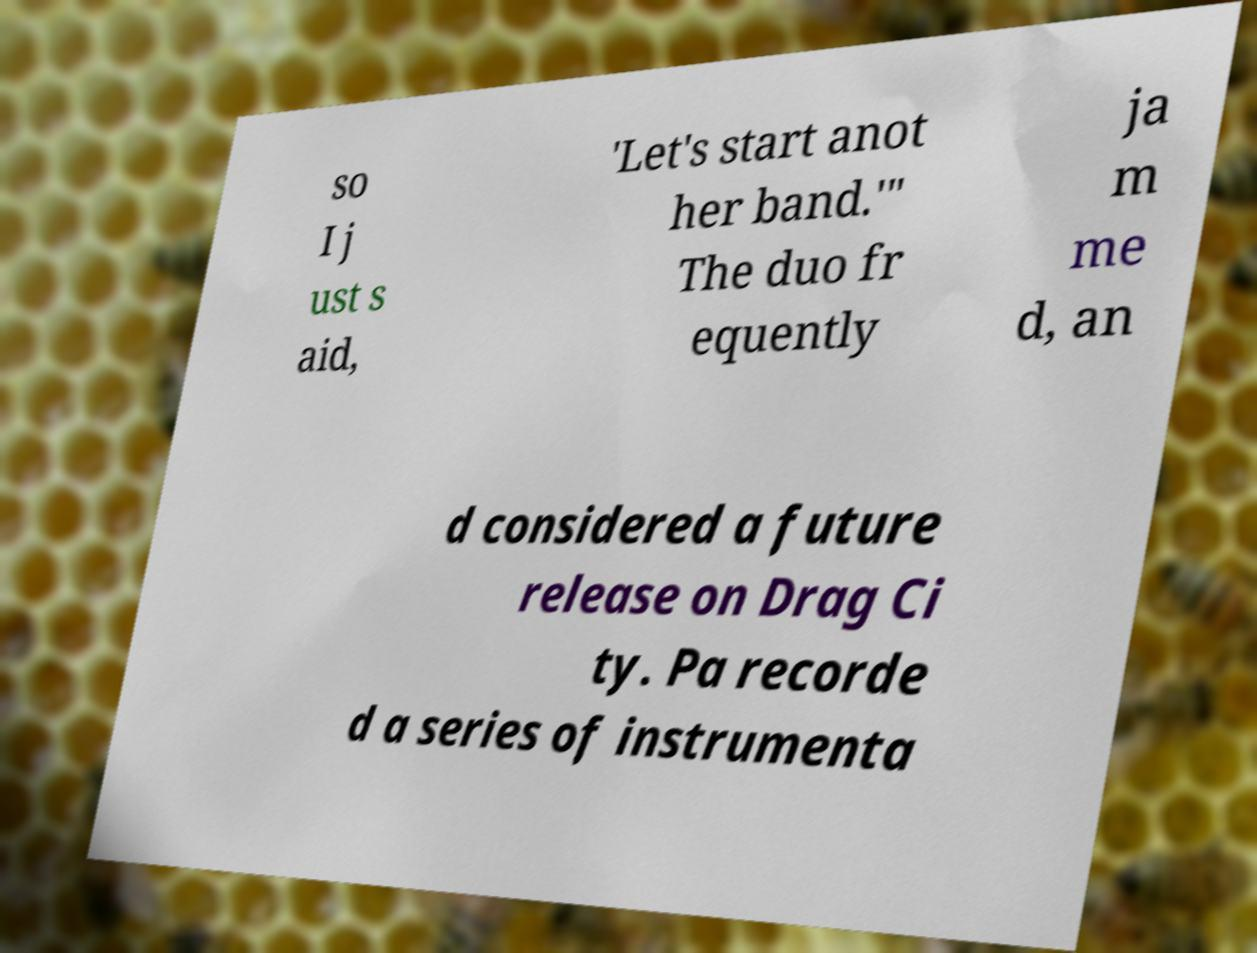Could you assist in decoding the text presented in this image and type it out clearly? so I j ust s aid, 'Let's start anot her band.'" The duo fr equently ja m me d, an d considered a future release on Drag Ci ty. Pa recorde d a series of instrumenta 